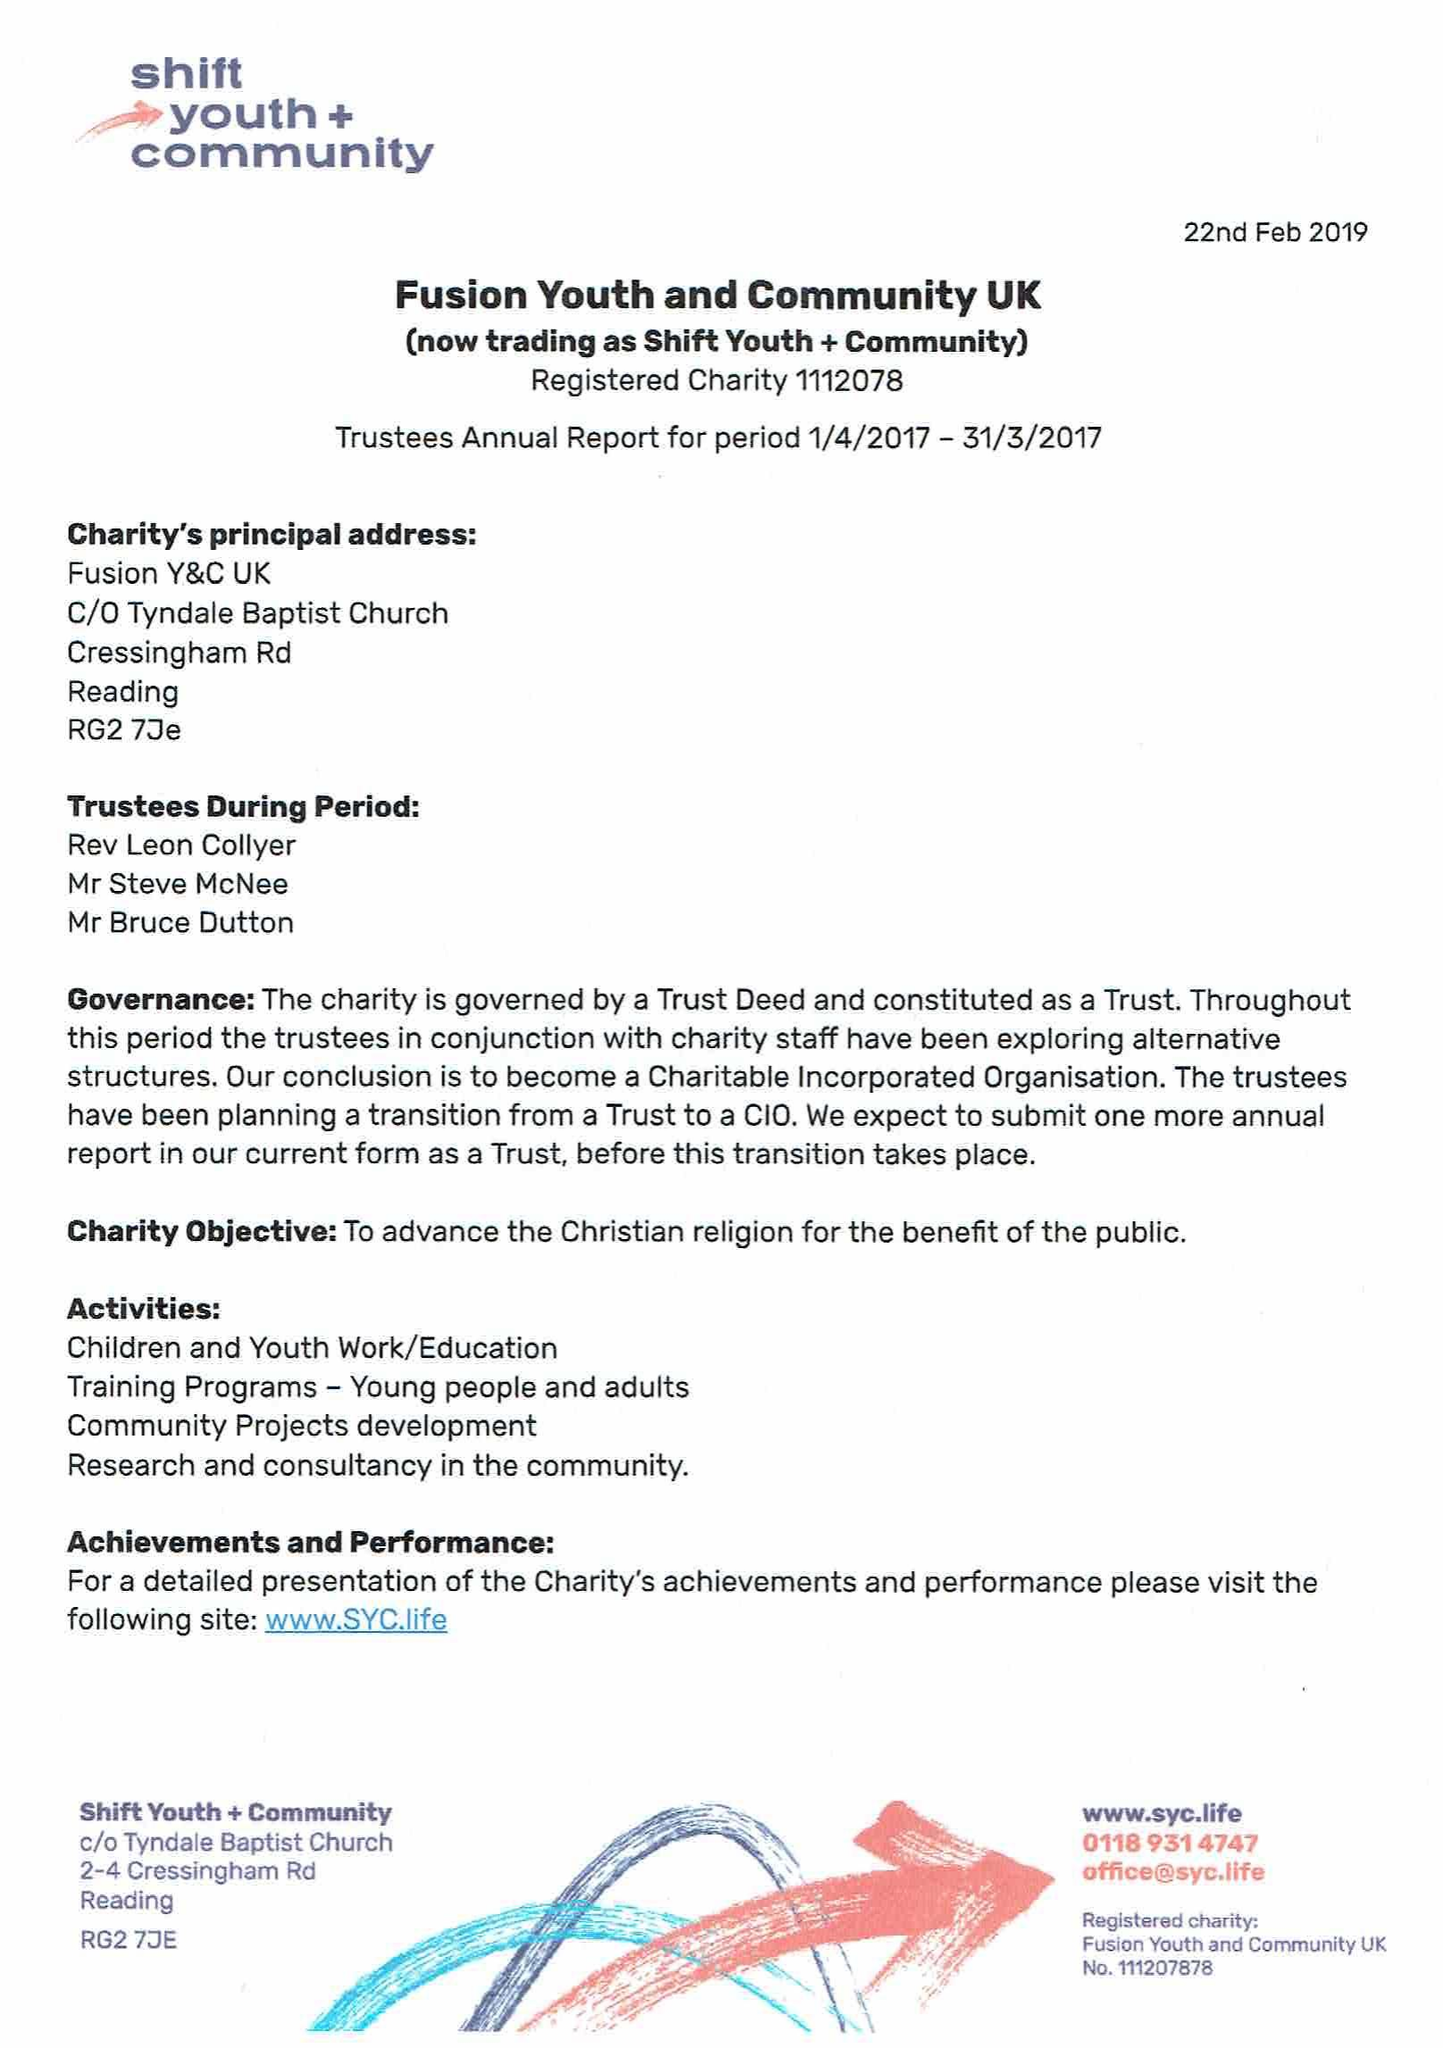What is the value for the charity_name?
Answer the question using a single word or phrase. Fusion Youth and Community Uk 